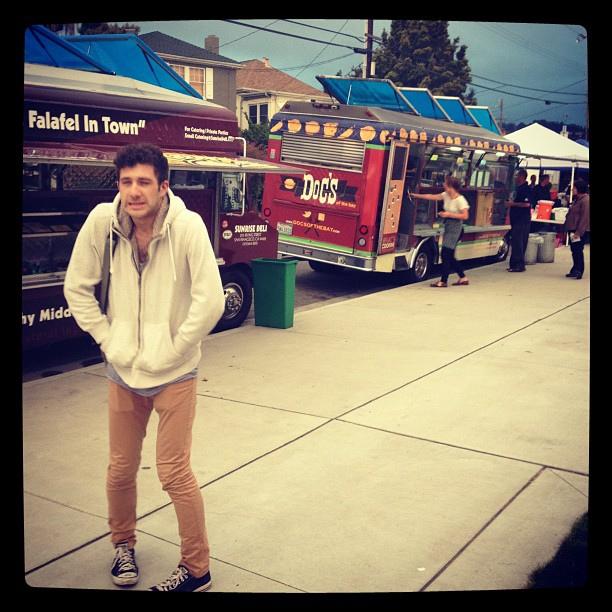What color is his jacket?
Give a very brief answer. White. What color are the trucks?
Keep it brief. Red. How many white squares are there?
Keep it brief. 4. What does the red sign say?
Concise answer only. Doc's. Is the man cold?
Short answer required. Yes. Is this a subway?
Keep it brief. No. What color are the shoes of the boy in front with the white hat?
Short answer required. Black. 